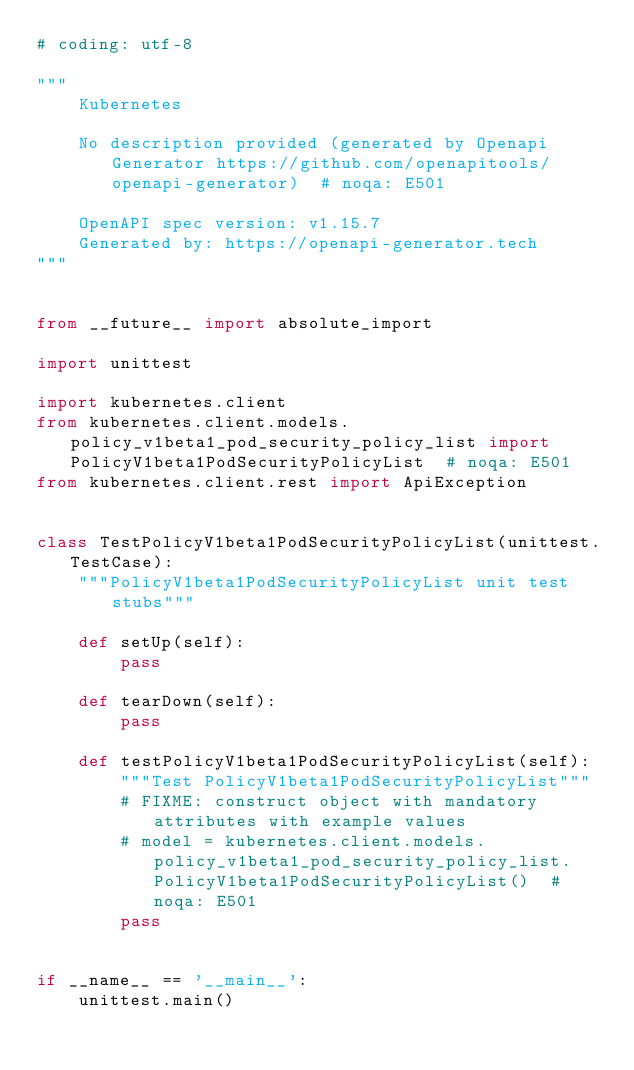<code> <loc_0><loc_0><loc_500><loc_500><_Python_># coding: utf-8

"""
    Kubernetes

    No description provided (generated by Openapi Generator https://github.com/openapitools/openapi-generator)  # noqa: E501

    OpenAPI spec version: v1.15.7
    Generated by: https://openapi-generator.tech
"""


from __future__ import absolute_import

import unittest

import kubernetes.client
from kubernetes.client.models.policy_v1beta1_pod_security_policy_list import PolicyV1beta1PodSecurityPolicyList  # noqa: E501
from kubernetes.client.rest import ApiException


class TestPolicyV1beta1PodSecurityPolicyList(unittest.TestCase):
    """PolicyV1beta1PodSecurityPolicyList unit test stubs"""

    def setUp(self):
        pass

    def tearDown(self):
        pass

    def testPolicyV1beta1PodSecurityPolicyList(self):
        """Test PolicyV1beta1PodSecurityPolicyList"""
        # FIXME: construct object with mandatory attributes with example values
        # model = kubernetes.client.models.policy_v1beta1_pod_security_policy_list.PolicyV1beta1PodSecurityPolicyList()  # noqa: E501
        pass


if __name__ == '__main__':
    unittest.main()
</code> 